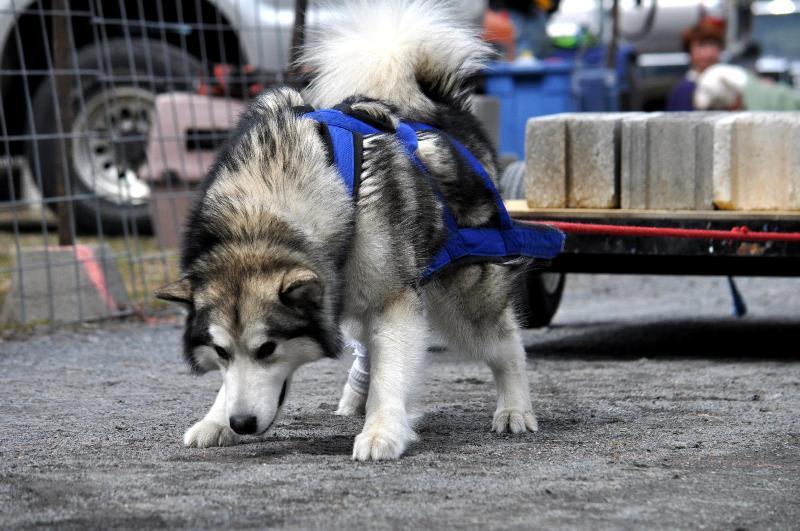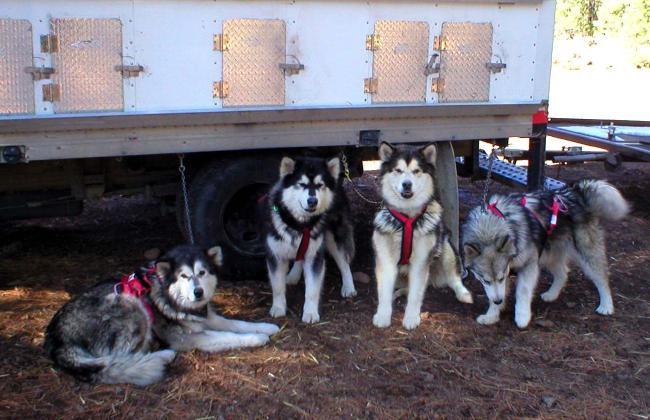The first image is the image on the left, the second image is the image on the right. Analyze the images presented: Is the assertion "In at least one image there is a single dog facing left that is trying to pull a stack of cement bricks." valid? Answer yes or no. Yes. 